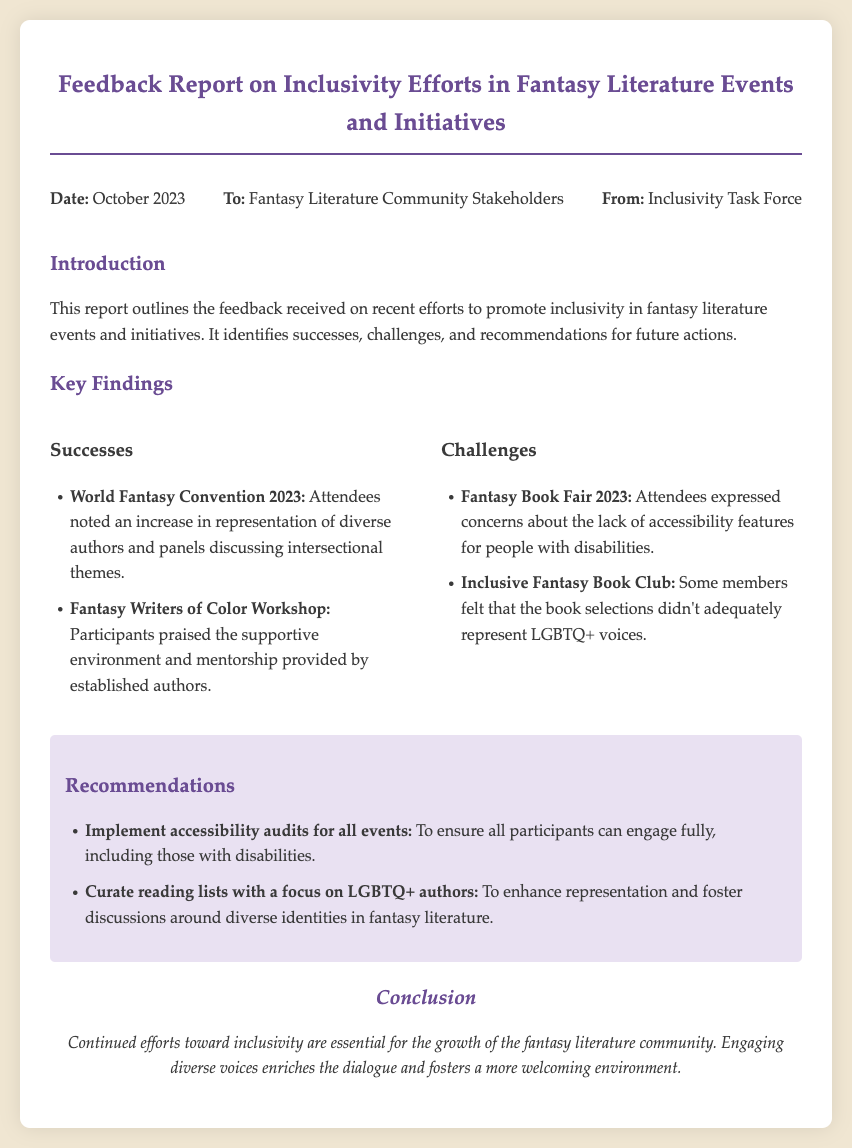What is the date of the report? The date of the report is specified in the header section of the document.
Answer: October 2023 Who is the report addressed to? The document specifies the intended audience in the header information.
Answer: Fantasy Literature Community Stakeholders What event had increased representation of diverse authors? This question refers to a specific successful initiative mentioned in the key findings section.
Answer: World Fantasy Convention 2023 What was a concern raised about the Fantasy Book Fair 2023? This question asks for a challenge listed in the document under key findings.
Answer: Lack of accessibility features What is one recommended action to enhance inclusivity? This question seeks to uncover a suggestion made in the recommendations section.
Answer: Implement accessibility audits for all events Which group praised the Fantasy Writers of Color Workshop? This question looks for who appreciated a successful initiative mentioned in the report.
Answer: Participants How does the conclusion summarize the importance of inclusivity? This question requires reasoning about the conclusion drawn in the memo regarding community growth.
Answer: Essential for the growth of the fantasy literature community What type of environment was provided by established authors in a workshop? This question seeks to understand the feedback given regarding a specific initiative.
Answer: Supportive environment 